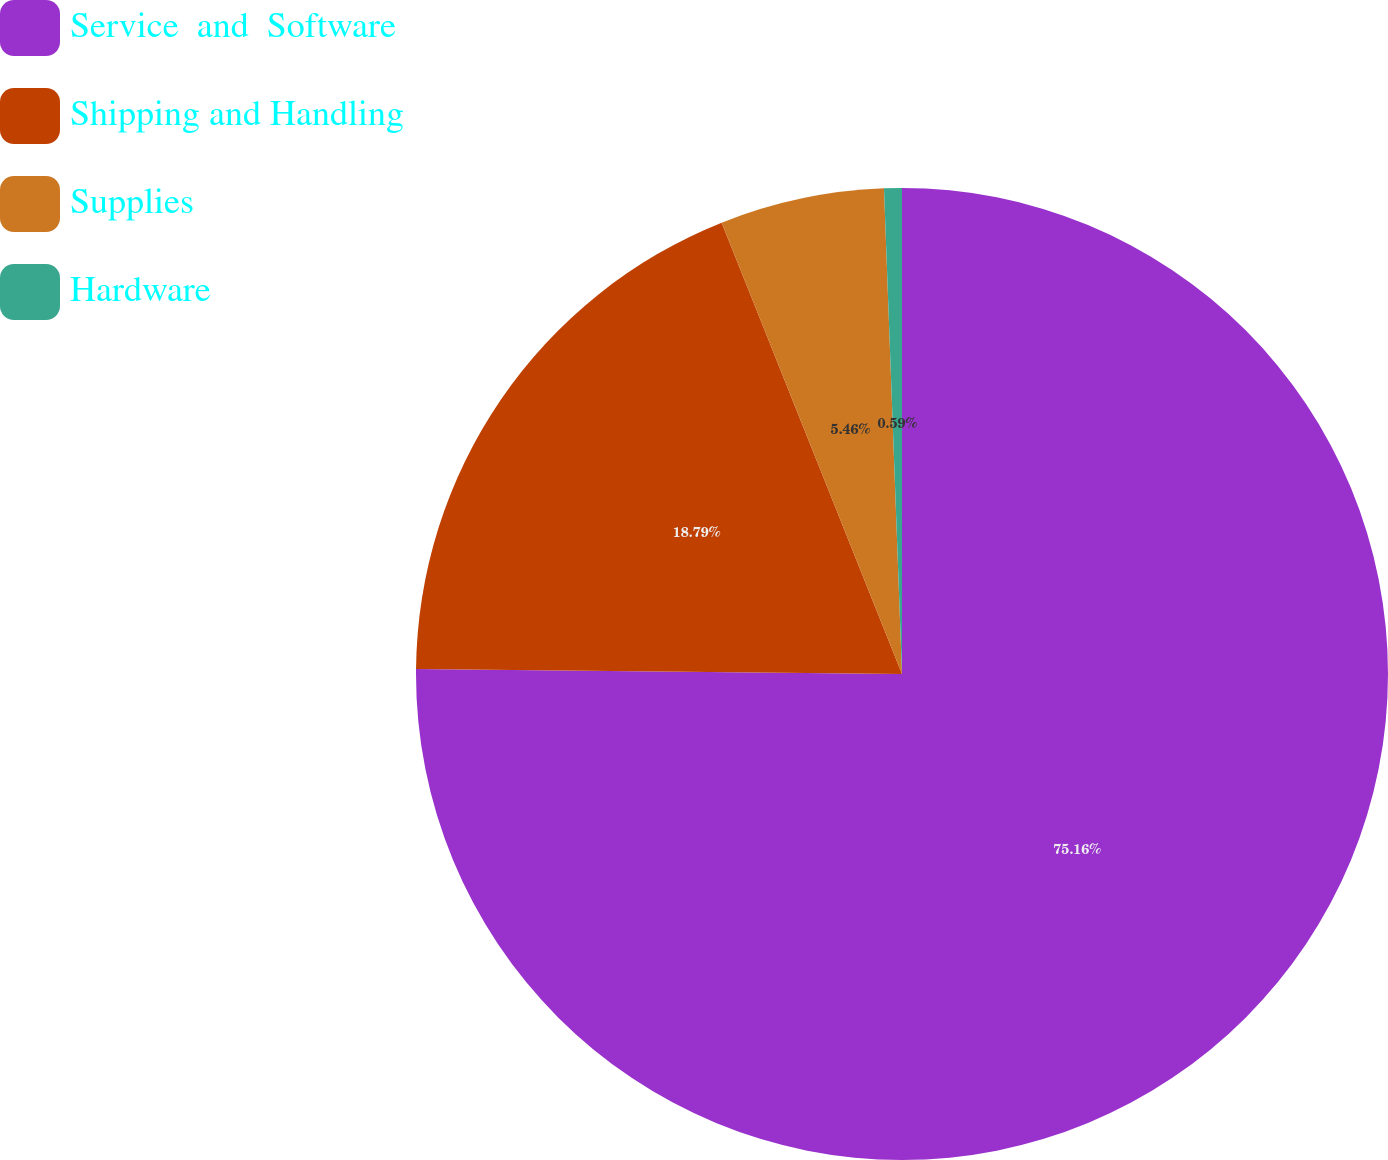<chart> <loc_0><loc_0><loc_500><loc_500><pie_chart><fcel>Service  and  Software<fcel>Shipping and Handling<fcel>Supplies<fcel>Hardware<nl><fcel>75.16%<fcel>18.79%<fcel>5.46%<fcel>0.59%<nl></chart> 